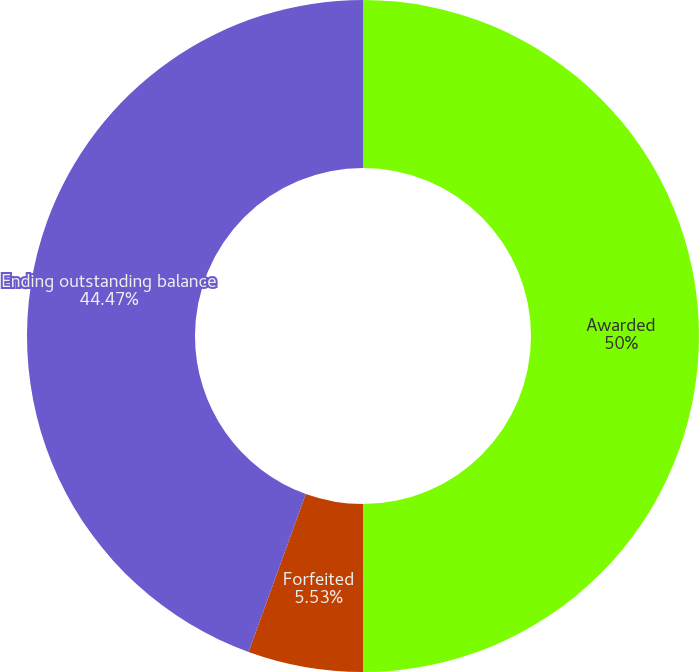Convert chart. <chart><loc_0><loc_0><loc_500><loc_500><pie_chart><fcel>Awarded<fcel>Forfeited<fcel>Ending outstanding balance<nl><fcel>50.0%<fcel>5.53%<fcel>44.47%<nl></chart> 